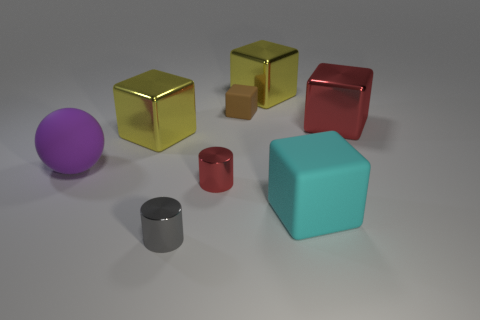Subtract all yellow cubes. How many were subtracted if there are1yellow cubes left? 1 Subtract all red metal blocks. How many blocks are left? 4 Subtract all cyan cubes. How many cubes are left? 4 Subtract all purple cylinders. How many cyan blocks are left? 1 Subtract all balls. How many objects are left? 7 Subtract 1 cylinders. How many cylinders are left? 1 Subtract all brown cylinders. Subtract all brown balls. How many cylinders are left? 2 Subtract all tiny gray things. Subtract all tiny objects. How many objects are left? 4 Add 1 purple spheres. How many purple spheres are left? 2 Add 3 small gray objects. How many small gray objects exist? 4 